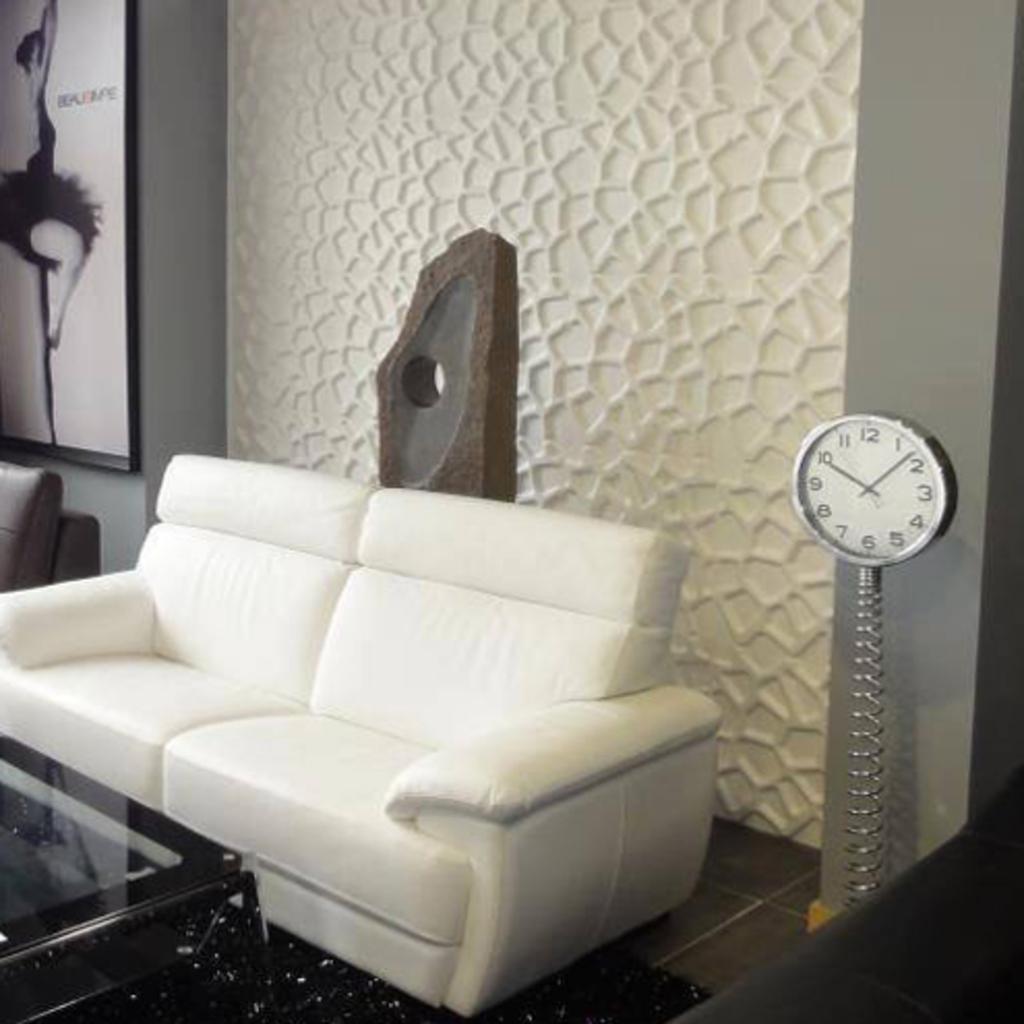What time is it?
Provide a succinct answer. 10:08. Which time of the clock?
Keep it short and to the point. 10:08. 